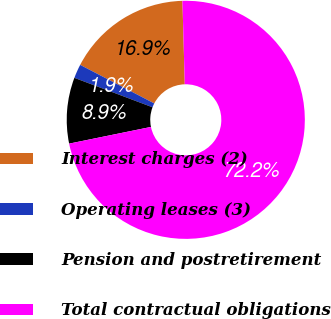Convert chart to OTSL. <chart><loc_0><loc_0><loc_500><loc_500><pie_chart><fcel>Interest charges (2)<fcel>Operating leases (3)<fcel>Pension and postretirement<fcel>Total contractual obligations<nl><fcel>16.92%<fcel>1.9%<fcel>8.94%<fcel>72.24%<nl></chart> 